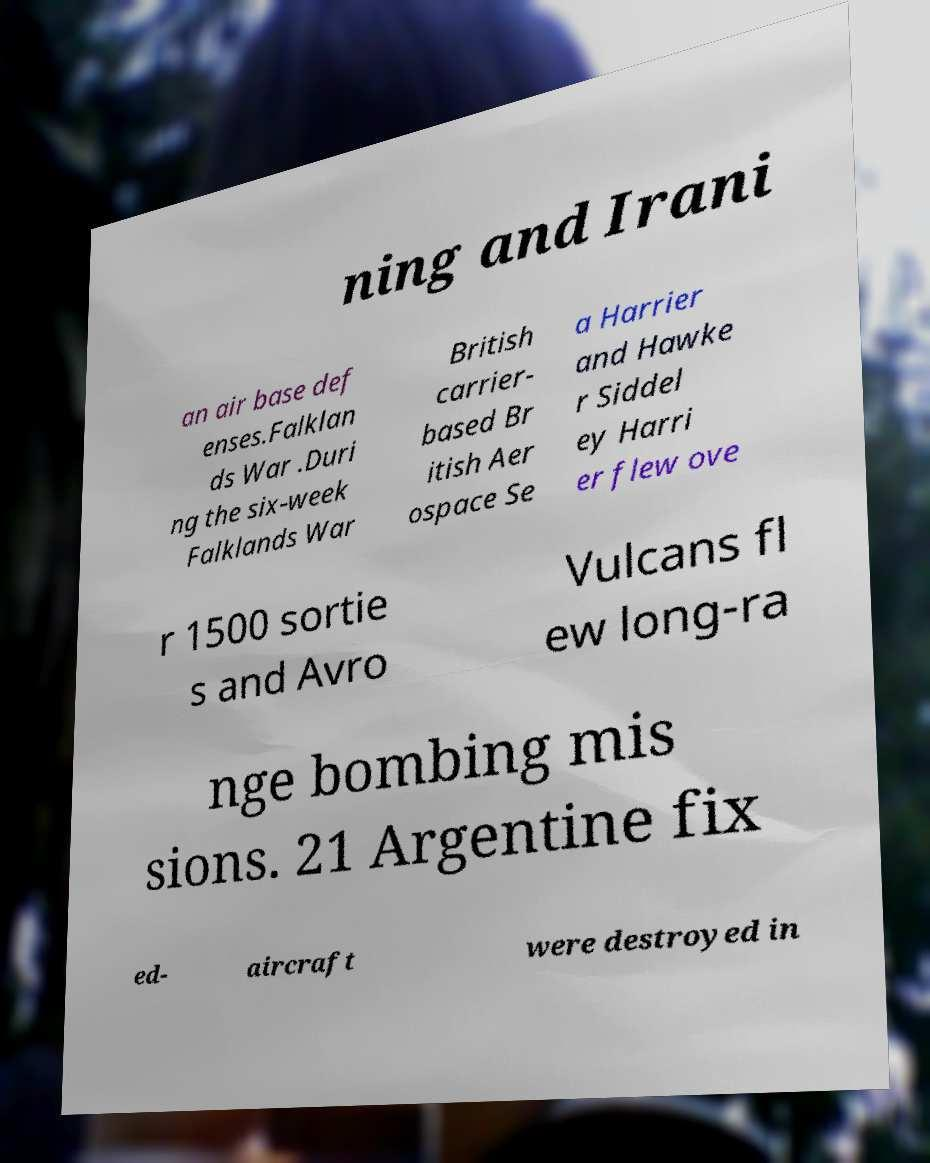There's text embedded in this image that I need extracted. Can you transcribe it verbatim? ning and Irani an air base def enses.Falklan ds War .Duri ng the six-week Falklands War British carrier- based Br itish Aer ospace Se a Harrier and Hawke r Siddel ey Harri er flew ove r 1500 sortie s and Avro Vulcans fl ew long-ra nge bombing mis sions. 21 Argentine fix ed- aircraft were destroyed in 